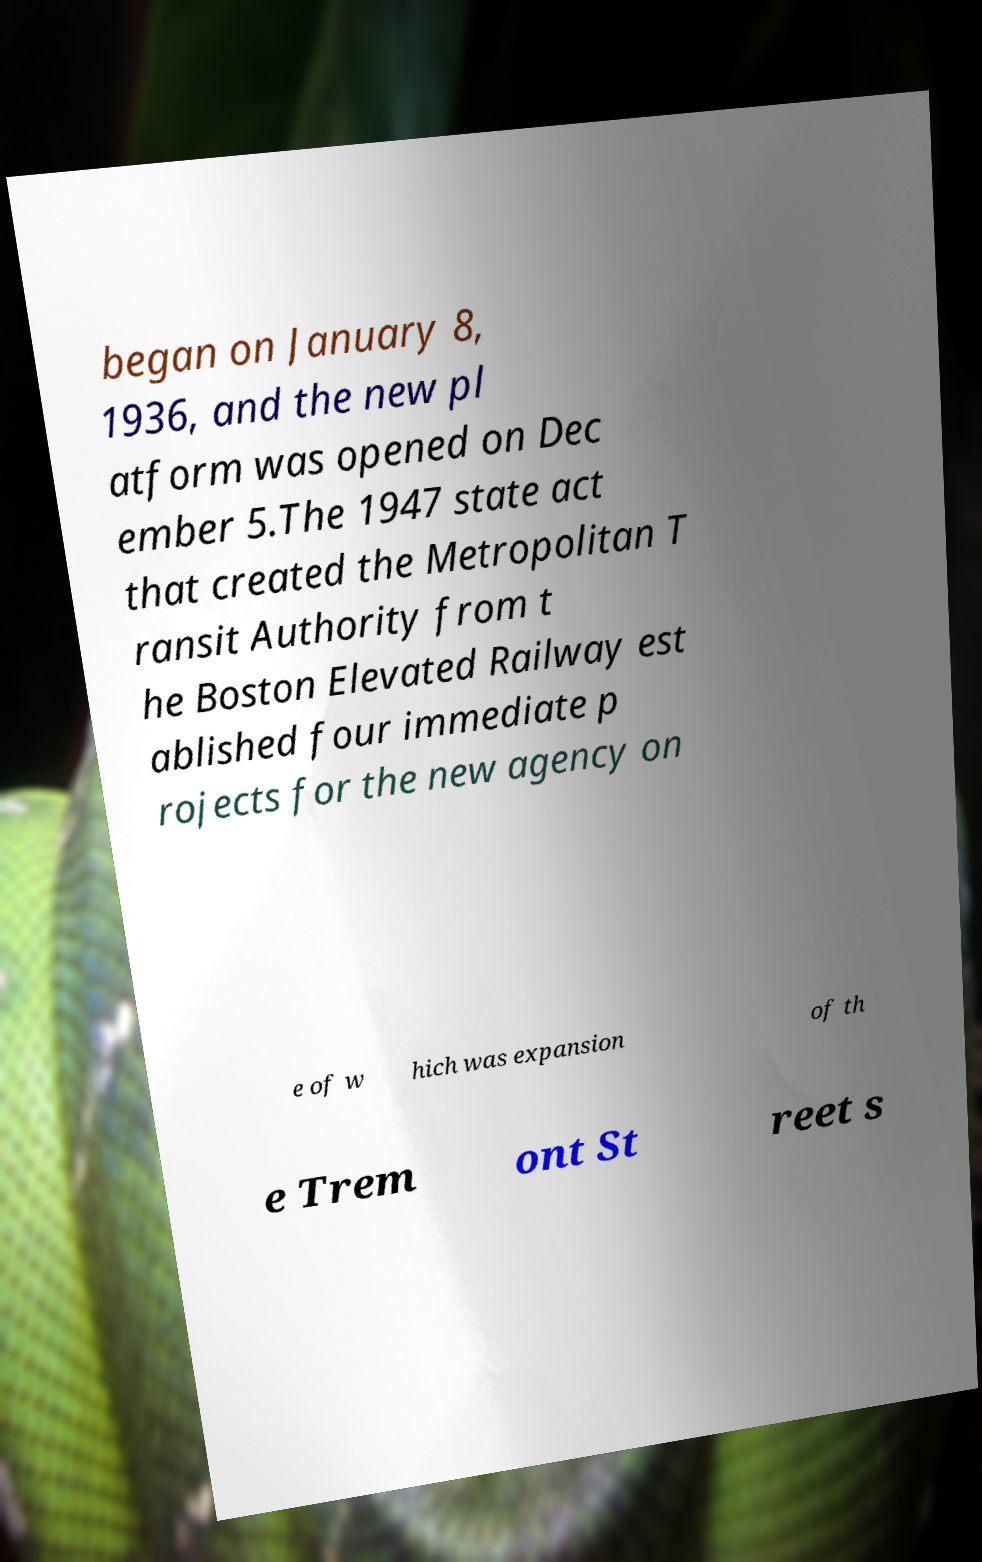What messages or text are displayed in this image? I need them in a readable, typed format. began on January 8, 1936, and the new pl atform was opened on Dec ember 5.The 1947 state act that created the Metropolitan T ransit Authority from t he Boston Elevated Railway est ablished four immediate p rojects for the new agency on e of w hich was expansion of th e Trem ont St reet s 